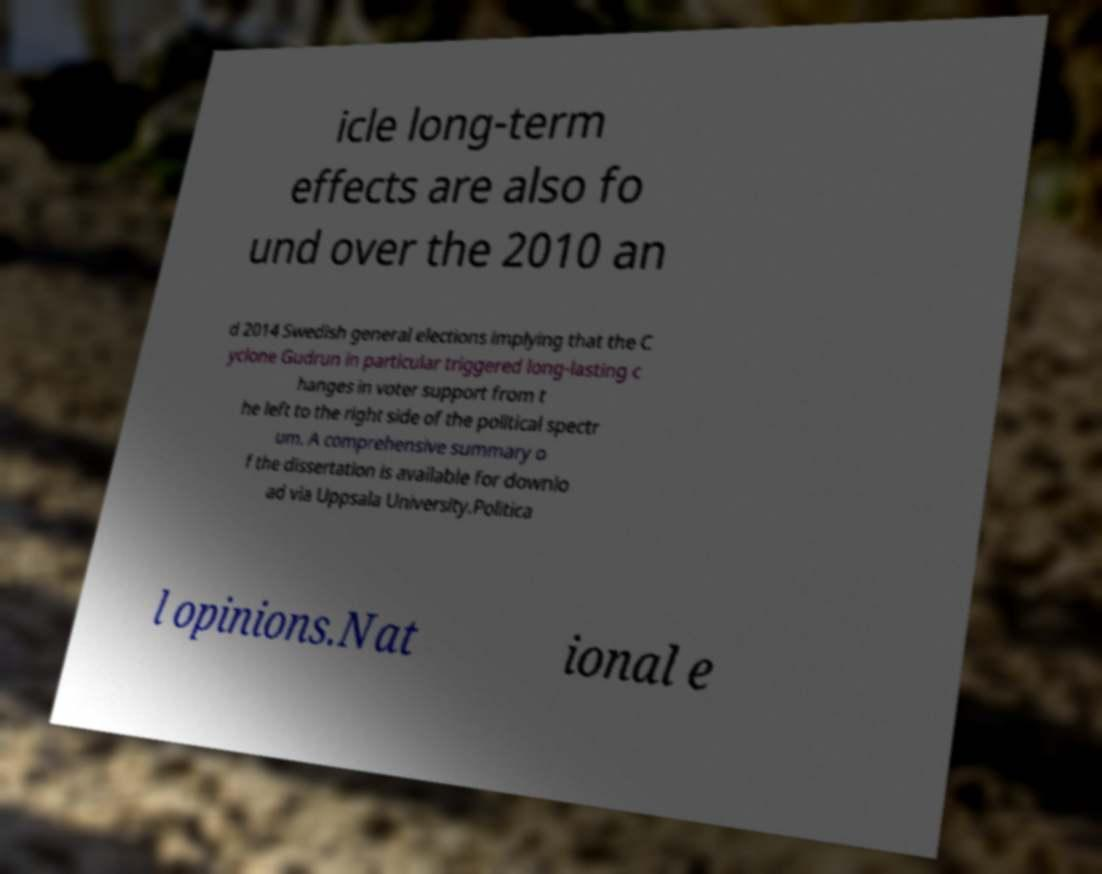Could you assist in decoding the text presented in this image and type it out clearly? icle long-term effects are also fo und over the 2010 an d 2014 Swedish general elections implying that the C yclone Gudrun in particular triggered long-lasting c hanges in voter support from t he left to the right side of the political spectr um. A comprehensive summary o f the dissertation is available for downlo ad via Uppsala University.Politica l opinions.Nat ional e 